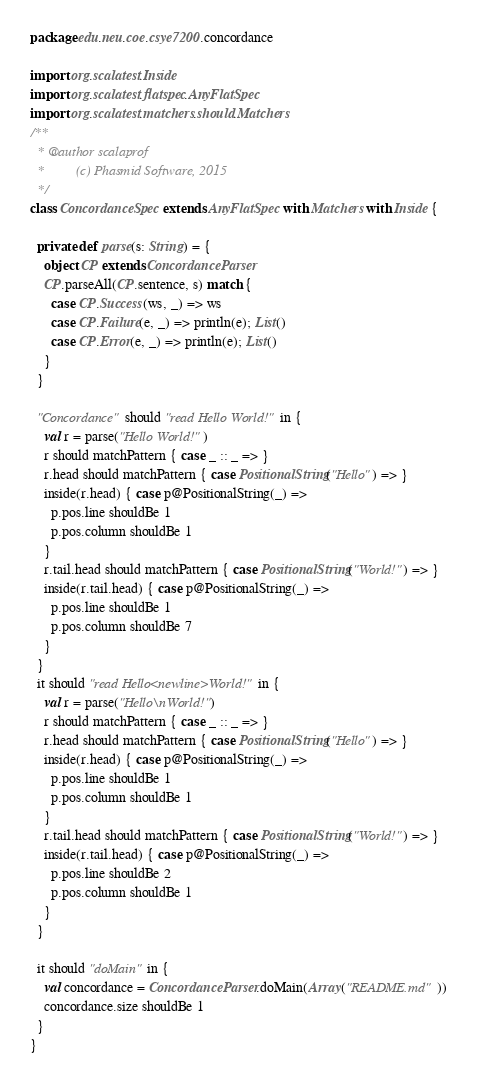<code> <loc_0><loc_0><loc_500><loc_500><_Scala_>package edu.neu.coe.csye7200.concordance

import org.scalatest.Inside
import org.scalatest.flatspec.AnyFlatSpec
import org.scalatest.matchers.should.Matchers
/**
  * @author scalaprof
  *         (c) Phasmid Software, 2015
  */
class ConcordanceSpec extends AnyFlatSpec with Matchers with Inside {

  private def parse(s: String) = {
    object CP extends ConcordanceParser
    CP.parseAll(CP.sentence, s) match {
      case CP.Success(ws, _) => ws
      case CP.Failure(e, _) => println(e); List()
      case CP.Error(e, _) => println(e); List()
    }
  }

  "Concordance" should "read Hello World!" in {
    val r = parse("Hello World!")
    r should matchPattern { case _ :: _ => }
    r.head should matchPattern { case PositionalString("Hello") => }
    inside(r.head) { case p@PositionalString(_) =>
      p.pos.line shouldBe 1
      p.pos.column shouldBe 1
    }
    r.tail.head should matchPattern { case PositionalString("World!") => }
    inside(r.tail.head) { case p@PositionalString(_) =>
      p.pos.line shouldBe 1
      p.pos.column shouldBe 7
    }
  }
  it should "read Hello<newline>World!" in {
    val r = parse("Hello\nWorld!")
    r should matchPattern { case _ :: _ => }
    r.head should matchPattern { case PositionalString("Hello") => }
    inside(r.head) { case p@PositionalString(_) =>
      p.pos.line shouldBe 1
      p.pos.column shouldBe 1
    }
    r.tail.head should matchPattern { case PositionalString("World!") => }
    inside(r.tail.head) { case p@PositionalString(_) =>
      p.pos.line shouldBe 2
      p.pos.column shouldBe 1
    }
  }

  it should "doMain" in {
    val concordance = ConcordanceParser.doMain(Array("README.md"))
    concordance.size shouldBe 1
  }
}
</code> 